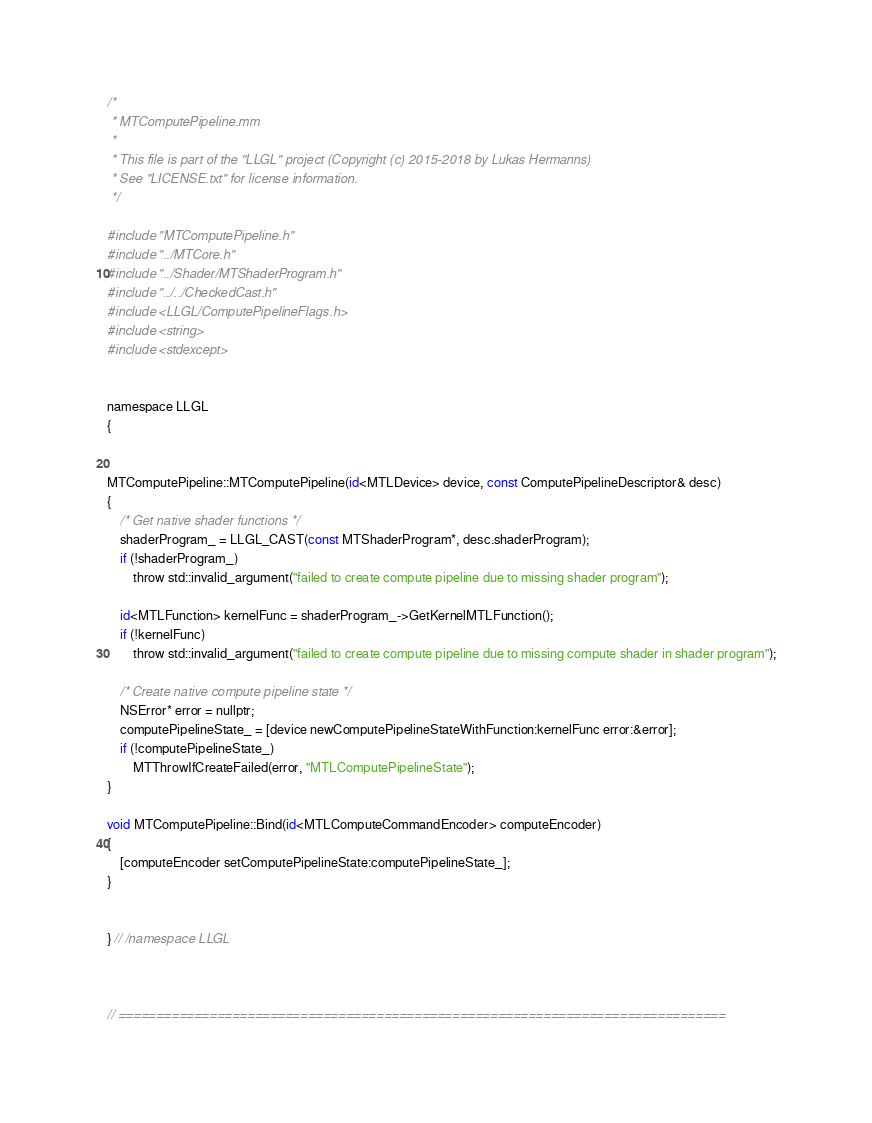Convert code to text. <code><loc_0><loc_0><loc_500><loc_500><_ObjectiveC_>/*
 * MTComputePipeline.mm
 * 
 * This file is part of the "LLGL" project (Copyright (c) 2015-2018 by Lukas Hermanns)
 * See "LICENSE.txt" for license information.
 */

#include "MTComputePipeline.h"
#include "../MTCore.h"
#include "../Shader/MTShaderProgram.h"
#include "../../CheckedCast.h"
#include <LLGL/ComputePipelineFlags.h>
#include <string>
#include <stdexcept>


namespace LLGL
{


MTComputePipeline::MTComputePipeline(id<MTLDevice> device, const ComputePipelineDescriptor& desc)
{
    /* Get native shader functions */
    shaderProgram_ = LLGL_CAST(const MTShaderProgram*, desc.shaderProgram);
    if (!shaderProgram_)
        throw std::invalid_argument("failed to create compute pipeline due to missing shader program");

    id<MTLFunction> kernelFunc = shaderProgram_->GetKernelMTLFunction();
    if (!kernelFunc)
        throw std::invalid_argument("failed to create compute pipeline due to missing compute shader in shader program");

    /* Create native compute pipeline state */
    NSError* error = nullptr;
    computePipelineState_ = [device newComputePipelineStateWithFunction:kernelFunc error:&error];
    if (!computePipelineState_)
        MTThrowIfCreateFailed(error, "MTLComputePipelineState");
}

void MTComputePipeline::Bind(id<MTLComputeCommandEncoder> computeEncoder)
{
    [computeEncoder setComputePipelineState:computePipelineState_];
}


} // /namespace LLGL



// ================================================================================
</code> 